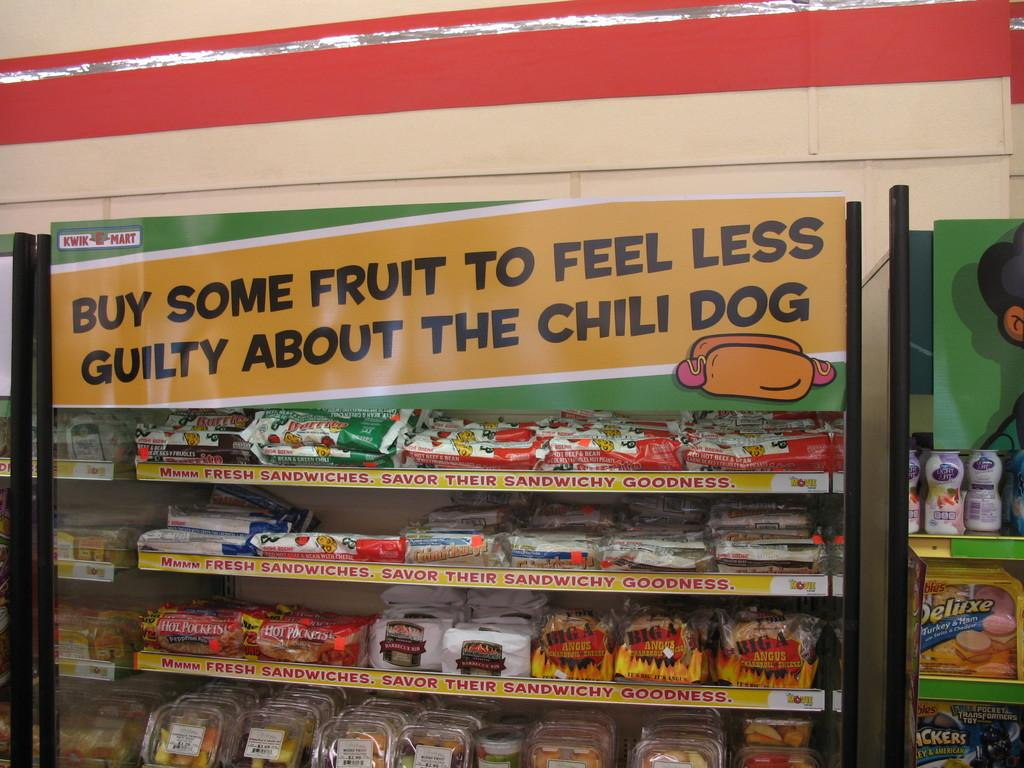<image>
Describe the image concisely. A convenience store sign above the junk food shelves makes a joke about eating fruit. 